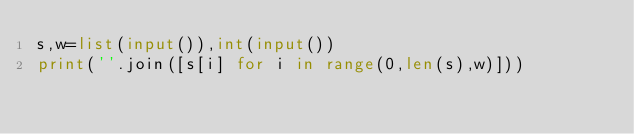Convert code to text. <code><loc_0><loc_0><loc_500><loc_500><_Python_>s,w=list(input()),int(input())
print(''.join([s[i] for i in range(0,len(s),w)]))</code> 